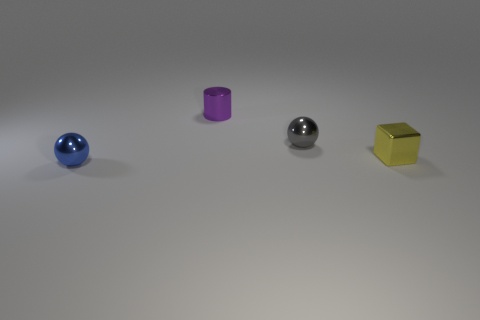Add 4 tiny gray metallic cylinders. How many objects exist? 8 Subtract 1 balls. How many balls are left? 1 Subtract all gray spheres. How many spheres are left? 1 Subtract all cylinders. How many objects are left? 3 Add 1 purple shiny cylinders. How many purple shiny cylinders exist? 2 Subtract 0 blue blocks. How many objects are left? 4 Subtract all yellow cylinders. Subtract all purple spheres. How many cylinders are left? 1 Subtract all cyan cylinders. How many green balls are left? 0 Subtract all large cyan cylinders. Subtract all small metal objects. How many objects are left? 0 Add 2 tiny blocks. How many tiny blocks are left? 3 